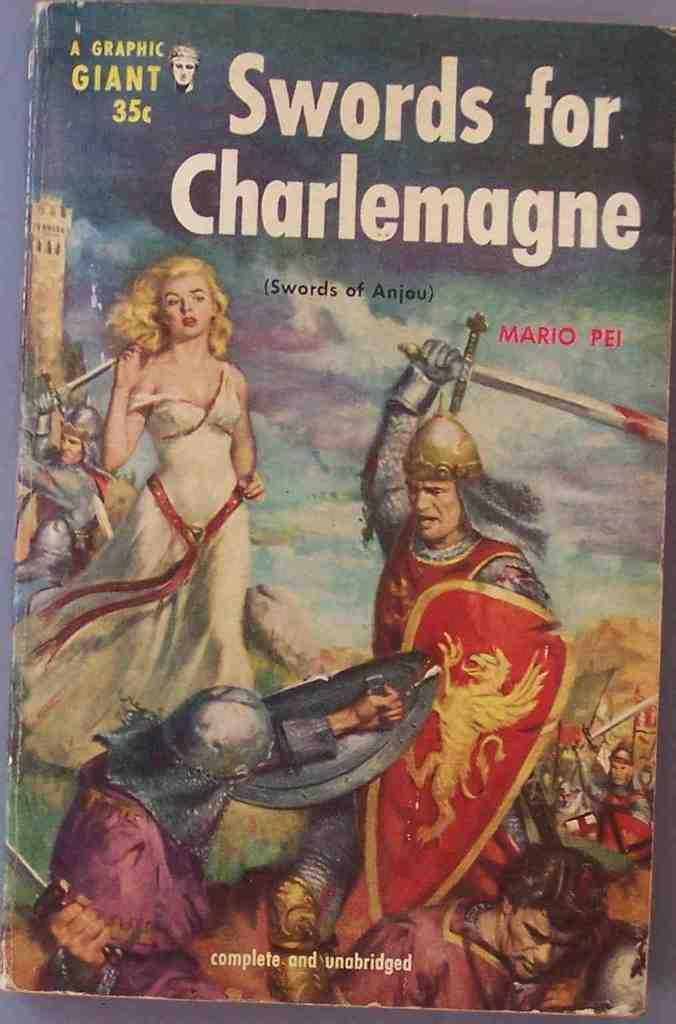<image>
Relay a brief, clear account of the picture shown. The book, Swords for Charlemagne, has a cover that makes it look old. 